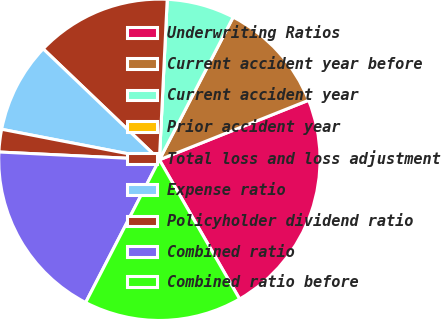Convert chart to OTSL. <chart><loc_0><loc_0><loc_500><loc_500><pie_chart><fcel>Underwriting Ratios<fcel>Current accident year before<fcel>Current accident year<fcel>Prior accident year<fcel>Total loss and loss adjustment<fcel>Expense ratio<fcel>Policyholder dividend ratio<fcel>Combined ratio<fcel>Combined ratio before<nl><fcel>22.72%<fcel>11.36%<fcel>6.82%<fcel>0.0%<fcel>13.64%<fcel>9.09%<fcel>2.27%<fcel>18.18%<fcel>15.91%<nl></chart> 